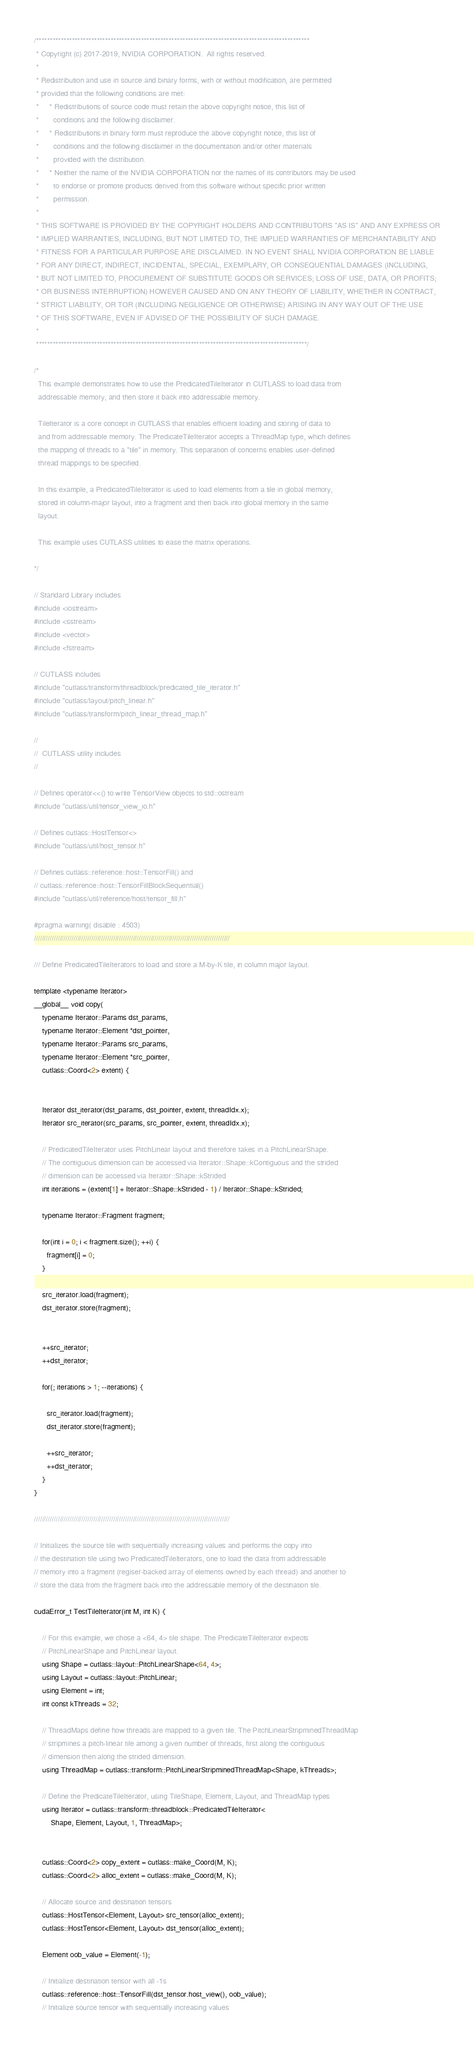<code> <loc_0><loc_0><loc_500><loc_500><_Cuda_>/***************************************************************************************************
 * Copyright (c) 2017-2019, NVIDIA CORPORATION.  All rights reserved.
 *
 * Redistribution and use in source and binary forms, with or without modification, are permitted
 * provided that the following conditions are met:
 *     * Redistributions of source code must retain the above copyright notice, this list of
 *       conditions and the following disclaimer.
 *     * Redistributions in binary form must reproduce the above copyright notice, this list of
 *       conditions and the following disclaimer in the documentation and/or other materials
 *       provided with the distribution.
 *     * Neither the name of the NVIDIA CORPORATION nor the names of its contributors may be used
 *       to endorse or promote products derived from this software without specific prior written
 *       permission.
 *
 * THIS SOFTWARE IS PROVIDED BY THE COPYRIGHT HOLDERS AND CONTRIBUTORS "AS IS" AND ANY EXPRESS OR
 * IMPLIED WARRANTIES, INCLUDING, BUT NOT LIMITED TO, THE IMPLIED WARRANTIES OF MERCHANTABILITY AND
 * FITNESS FOR A PARTICULAR PURPOSE ARE DISCLAIMED. IN NO EVENT SHALL NVIDIA CORPORATION BE LIABLE
 * FOR ANY DIRECT, INDIRECT, INCIDENTAL, SPECIAL, EXEMPLARY, OR CONSEQUENTIAL DAMAGES (INCLUDING,
 * BUT NOT LIMITED TO, PROCUREMENT OF SUBSTITUTE GOODS OR SERVICES; LOSS OF USE, DATA, OR PROFITS;
 * OR BUSINESS INTERRUPTION) HOWEVER CAUSED AND ON ANY THEORY OF LIABILITY, WHETHER IN CONTRACT,
 * STRICT LIABILITY, OR TOR (INCLUDING NEGLIGENCE OR OTHERWISE) ARISING IN ANY WAY OUT OF THE USE
 * OF THIS SOFTWARE, EVEN IF ADVISED OF THE POSSIBILITY OF SUCH DAMAGE.
 *
 **************************************************************************************************/

/*
  This example demonstrates how to use the PredicatedTileIterator in CUTLASS to load data from
  addressable memory, and then store it back into addressable memory.

  TileIterator is a core concept in CUTLASS that enables efficient loading and storing of data to
  and from addressable memory. The PredicateTileIterator accepts a ThreadMap type, which defines
  the mapping of threads to a "tile" in memory. This separation of concerns enables user-defined
  thread mappings to be specified. 

  In this example, a PredicatedTileIterator is used to load elements from a tile in global memory,
  stored in column-major layout, into a fragment and then back into global memory in the same
  layout.

  This example uses CUTLASS utilities to ease the matrix operations.

*/

// Standard Library includes
#include <iostream>
#include <sstream>
#include <vector>
#include <fstream>

// CUTLASS includes
#include "cutlass/transform/threadblock/predicated_tile_iterator.h"
#include "cutlass/layout/pitch_linear.h"
#include "cutlass/transform/pitch_linear_thread_map.h"

//
//  CUTLASS utility includes
//

// Defines operator<<() to write TensorView objects to std::ostream
#include "cutlass/util/tensor_view_io.h"

// Defines cutlass::HostTensor<>
#include "cutlass/util/host_tensor.h"

// Defines cutlass::reference::host::TensorFill() and
// cutlass::reference::host::TensorFillBlockSequential()
#include "cutlass/util/reference/host/tensor_fill.h"

#pragma warning( disable : 4503)
///////////////////////////////////////////////////////////////////////////////////////////////////

/// Define PredicatedTileIterators to load and store a M-by-K tile, in column major layout.

template <typename Iterator>
__global__ void copy(
    typename Iterator::Params dst_params,
    typename Iterator::Element *dst_pointer,
    typename Iterator::Params src_params,
    typename Iterator::Element *src_pointer,
    cutlass::Coord<2> extent) {


    Iterator dst_iterator(dst_params, dst_pointer, extent, threadIdx.x);
    Iterator src_iterator(src_params, src_pointer, extent, threadIdx.x);

    // PredicatedTileIterator uses PitchLinear layout and therefore takes in a PitchLinearShape.
    // The contiguous dimension can be accessed via Iterator::Shape::kContiguous and the strided
    // dimension can be accessed via Iterator::Shape::kStrided
    int iterations = (extent[1] + Iterator::Shape::kStrided - 1) / Iterator::Shape::kStrided;

    typename Iterator::Fragment fragment;

    for(int i = 0; i < fragment.size(); ++i) {
      fragment[i] = 0;
    }

    src_iterator.load(fragment);
    dst_iterator.store(fragment);


    ++src_iterator;
    ++dst_iterator;

    for(; iterations > 1; --iterations) {

      src_iterator.load(fragment);
      dst_iterator.store(fragment);

      ++src_iterator;
      ++dst_iterator;
    }
}

///////////////////////////////////////////////////////////////////////////////////////////////////

// Initializes the source tile with sequentially increasing values and performs the copy into
// the destination tile using two PredicatedTileIterators, one to load the data from addressable
// memory into a fragment (regiser-backed array of elements owned by each thread) and another to 
// store the data from the fragment back into the addressable memory of the destination tile.

cudaError_t TestTileIterator(int M, int K) {

    // For this example, we chose a <64, 4> tile shape. The PredicateTileIterator expects
    // PitchLinearShape and PitchLinear layout.
    using Shape = cutlass::layout::PitchLinearShape<64, 4>;
    using Layout = cutlass::layout::PitchLinear;
    using Element = int;
    int const kThreads = 32;

    // ThreadMaps define how threads are mapped to a given tile. The PitchLinearStripminedThreadMap
    // stripmines a pitch-linear tile among a given number of threads, first along the contiguous
    // dimension then along the strided dimension.
    using ThreadMap = cutlass::transform::PitchLinearStripminedThreadMap<Shape, kThreads>;

    // Define the PredicateTileIterator, using TileShape, Element, Layout, and ThreadMap types
    using Iterator = cutlass::transform::threadblock::PredicatedTileIterator<
        Shape, Element, Layout, 1, ThreadMap>;


    cutlass::Coord<2> copy_extent = cutlass::make_Coord(M, K);
    cutlass::Coord<2> alloc_extent = cutlass::make_Coord(M, K);

    // Allocate source and destination tensors
    cutlass::HostTensor<Element, Layout> src_tensor(alloc_extent);
    cutlass::HostTensor<Element, Layout> dst_tensor(alloc_extent);

    Element oob_value = Element(-1);

    // Initialize destination tensor with all -1s
    cutlass::reference::host::TensorFill(dst_tensor.host_view(), oob_value);
    // Initialize source tensor with sequentially increasing values</code> 